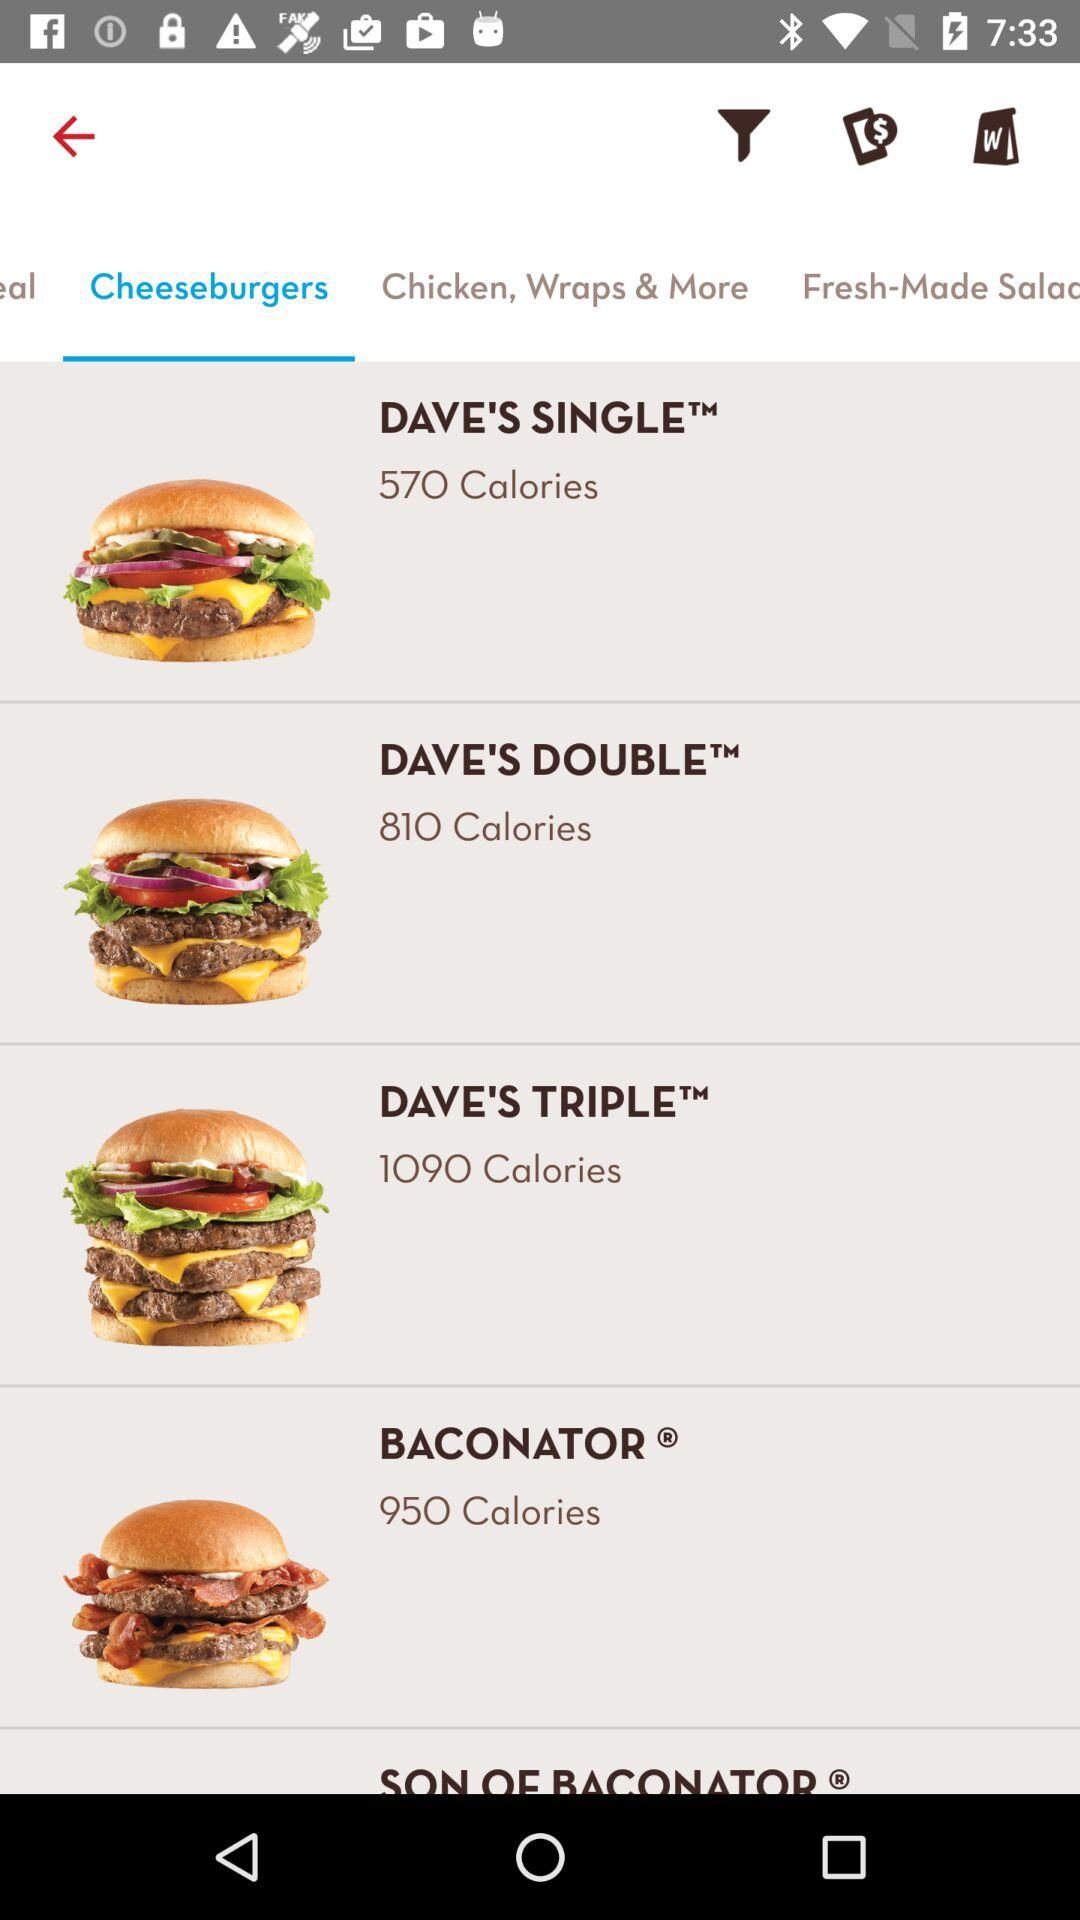How many calories are in "DAVE'S SINGLE"? There are 570 calories in "DAVE'S SINGLE". 